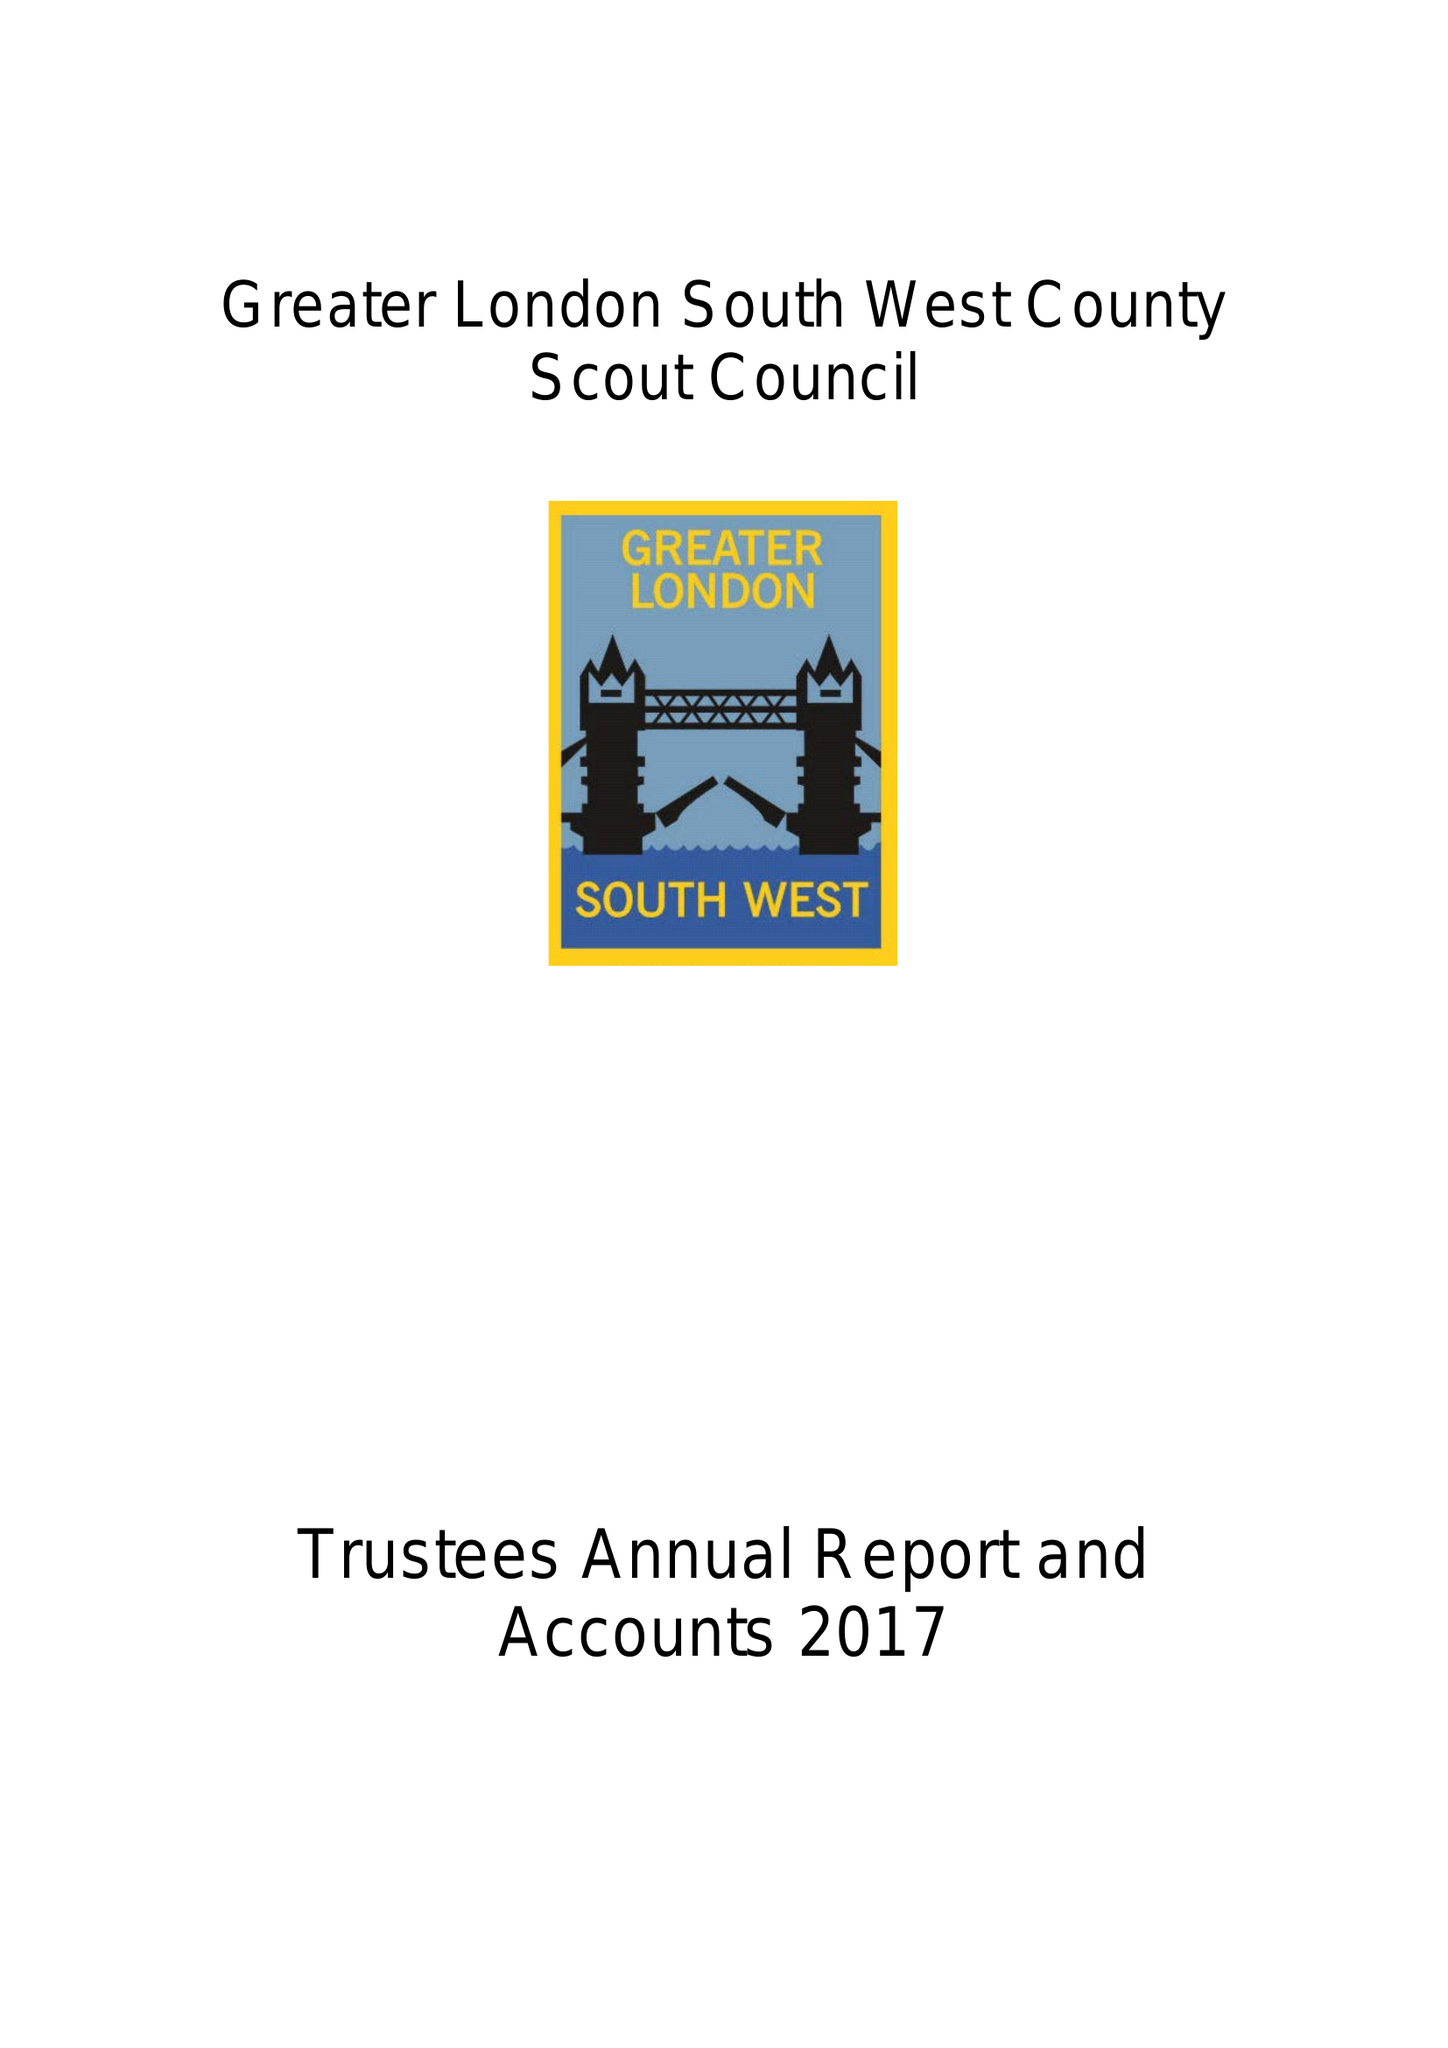What is the value for the report_date?
Answer the question using a single word or phrase. 2017-12-31 